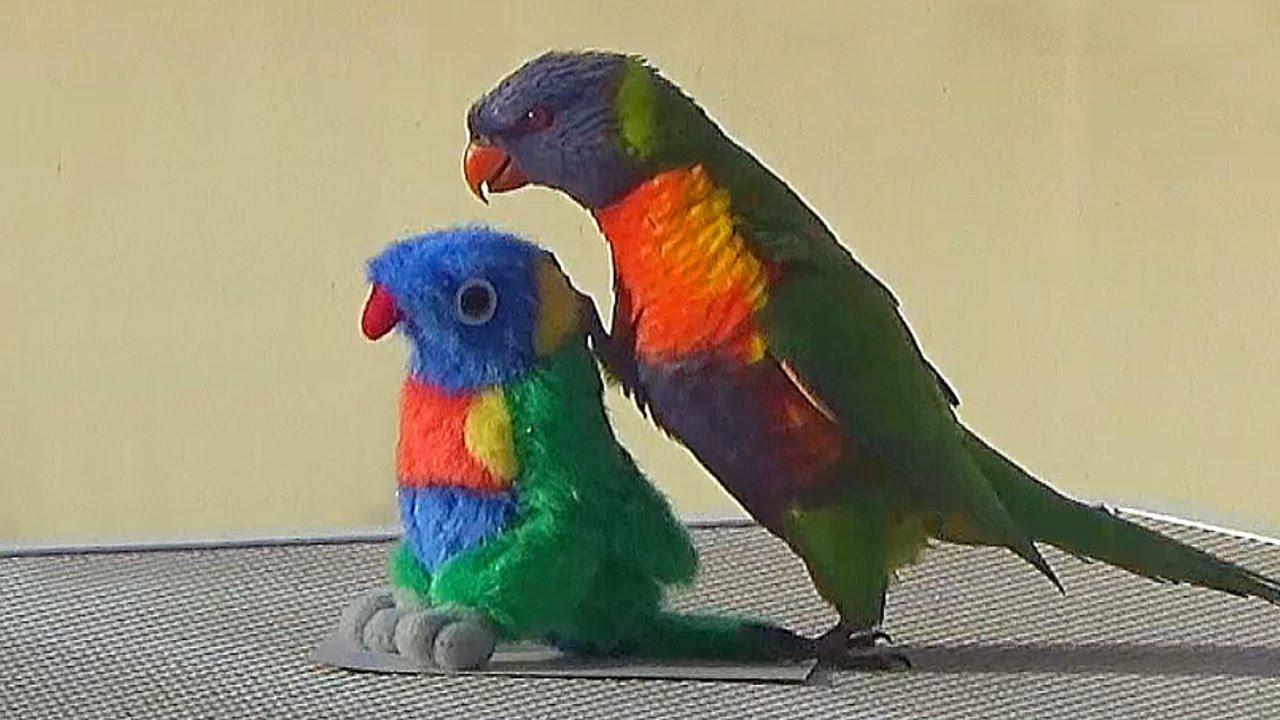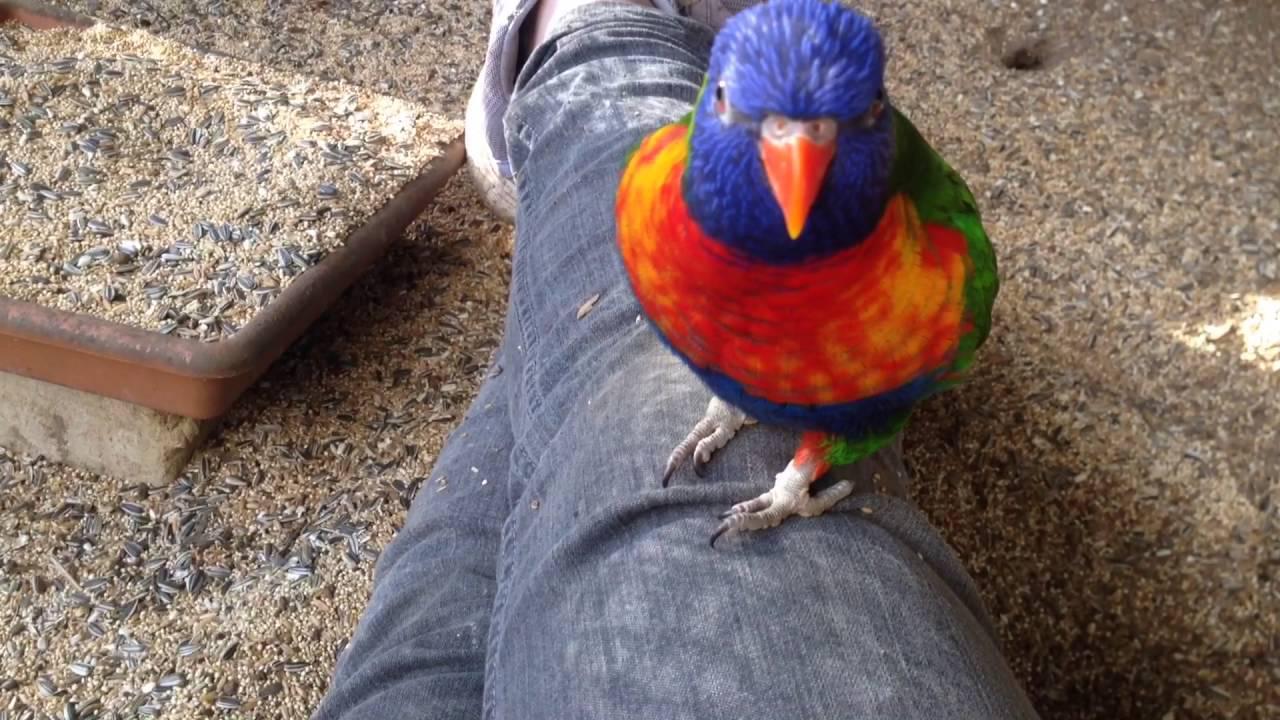The first image is the image on the left, the second image is the image on the right. For the images displayed, is the sentence "Left image shows a colorful parrot near a person's head." factually correct? Answer yes or no. No. The first image is the image on the left, the second image is the image on the right. Examine the images to the left and right. Is the description "The bird in the image on the left is standing on a person." accurate? Answer yes or no. No. 